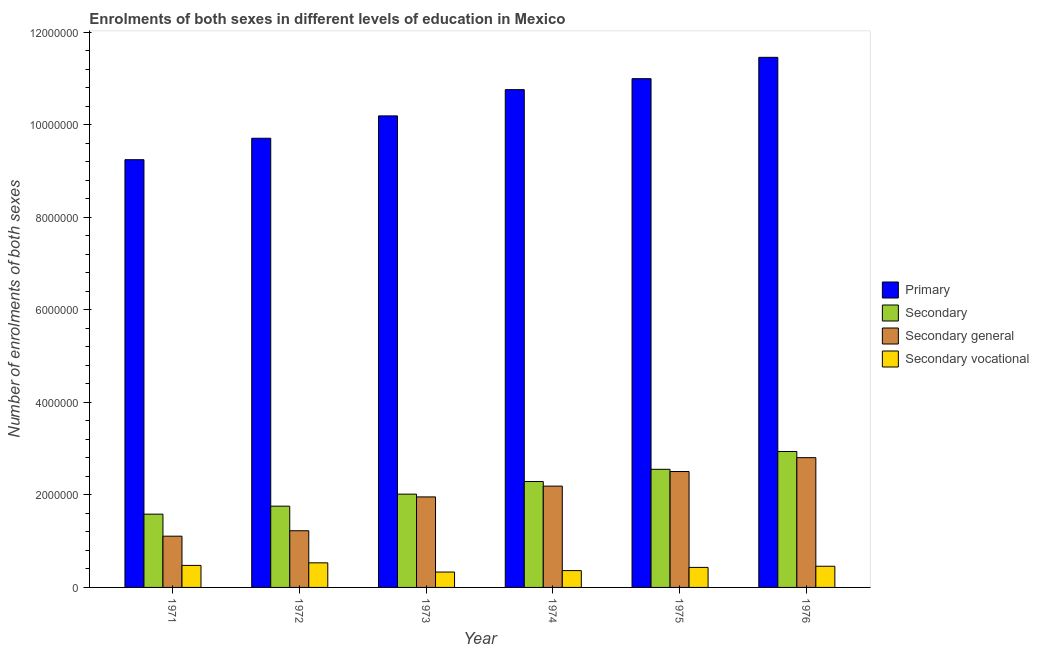How many different coloured bars are there?
Offer a very short reply. 4. Are the number of bars per tick equal to the number of legend labels?
Your answer should be compact. Yes. What is the label of the 4th group of bars from the left?
Your answer should be very brief. 1974. In how many cases, is the number of bars for a given year not equal to the number of legend labels?
Your response must be concise. 0. What is the number of enrolments in secondary education in 1971?
Offer a very short reply. 1.58e+06. Across all years, what is the maximum number of enrolments in secondary general education?
Ensure brevity in your answer.  2.81e+06. Across all years, what is the minimum number of enrolments in secondary education?
Provide a short and direct response. 1.58e+06. In which year was the number of enrolments in secondary general education minimum?
Your response must be concise. 1971. What is the total number of enrolments in secondary general education in the graph?
Give a very brief answer. 1.18e+07. What is the difference between the number of enrolments in secondary vocational education in 1974 and that in 1975?
Give a very brief answer. -6.93e+04. What is the difference between the number of enrolments in secondary general education in 1974 and the number of enrolments in secondary education in 1976?
Provide a short and direct response. -6.15e+05. What is the average number of enrolments in primary education per year?
Make the answer very short. 1.04e+07. In the year 1976, what is the difference between the number of enrolments in primary education and number of enrolments in secondary vocational education?
Provide a succinct answer. 0. In how many years, is the number of enrolments in secondary vocational education greater than 3200000?
Your response must be concise. 0. What is the ratio of the number of enrolments in secondary education in 1974 to that in 1976?
Your response must be concise. 0.78. Is the number of enrolments in secondary general education in 1971 less than that in 1972?
Your answer should be very brief. Yes. What is the difference between the highest and the second highest number of enrolments in secondary vocational education?
Offer a very short reply. 5.51e+04. What is the difference between the highest and the lowest number of enrolments in secondary vocational education?
Offer a very short reply. 1.99e+05. Is the sum of the number of enrolments in primary education in 1972 and 1975 greater than the maximum number of enrolments in secondary education across all years?
Make the answer very short. Yes. Is it the case that in every year, the sum of the number of enrolments in secondary vocational education and number of enrolments in primary education is greater than the sum of number of enrolments in secondary education and number of enrolments in secondary general education?
Keep it short and to the point. No. What does the 4th bar from the left in 1975 represents?
Keep it short and to the point. Secondary vocational. What does the 3rd bar from the right in 1973 represents?
Keep it short and to the point. Secondary. Is it the case that in every year, the sum of the number of enrolments in primary education and number of enrolments in secondary education is greater than the number of enrolments in secondary general education?
Give a very brief answer. Yes. How many bars are there?
Your answer should be very brief. 24. Are all the bars in the graph horizontal?
Ensure brevity in your answer.  No. Does the graph contain any zero values?
Provide a succinct answer. No. Where does the legend appear in the graph?
Give a very brief answer. Center right. How many legend labels are there?
Provide a short and direct response. 4. What is the title of the graph?
Offer a terse response. Enrolments of both sexes in different levels of education in Mexico. What is the label or title of the Y-axis?
Ensure brevity in your answer.  Number of enrolments of both sexes. What is the Number of enrolments of both sexes of Primary in 1971?
Offer a very short reply. 9.25e+06. What is the Number of enrolments of both sexes in Secondary in 1971?
Provide a short and direct response. 1.58e+06. What is the Number of enrolments of both sexes in Secondary general in 1971?
Your response must be concise. 1.11e+06. What is the Number of enrolments of both sexes in Secondary vocational in 1971?
Give a very brief answer. 4.76e+05. What is the Number of enrolments of both sexes of Primary in 1972?
Your response must be concise. 9.71e+06. What is the Number of enrolments of both sexes in Secondary in 1972?
Your answer should be compact. 1.76e+06. What is the Number of enrolments of both sexes of Secondary general in 1972?
Provide a succinct answer. 1.23e+06. What is the Number of enrolments of both sexes in Secondary vocational in 1972?
Your response must be concise. 5.32e+05. What is the Number of enrolments of both sexes of Primary in 1973?
Keep it short and to the point. 1.02e+07. What is the Number of enrolments of both sexes of Secondary in 1973?
Your answer should be very brief. 2.02e+06. What is the Number of enrolments of both sexes of Secondary general in 1973?
Keep it short and to the point. 1.96e+06. What is the Number of enrolments of both sexes of Secondary vocational in 1973?
Your answer should be very brief. 3.33e+05. What is the Number of enrolments of both sexes of Primary in 1974?
Provide a short and direct response. 1.08e+07. What is the Number of enrolments of both sexes of Secondary in 1974?
Offer a very short reply. 2.29e+06. What is the Number of enrolments of both sexes of Secondary general in 1974?
Your answer should be compact. 2.19e+06. What is the Number of enrolments of both sexes of Secondary vocational in 1974?
Offer a very short reply. 3.64e+05. What is the Number of enrolments of both sexes of Primary in 1975?
Offer a terse response. 1.10e+07. What is the Number of enrolments of both sexes in Secondary in 1975?
Offer a very short reply. 2.55e+06. What is the Number of enrolments of both sexes of Secondary general in 1975?
Keep it short and to the point. 2.51e+06. What is the Number of enrolments of both sexes of Secondary vocational in 1975?
Provide a short and direct response. 4.33e+05. What is the Number of enrolments of both sexes of Primary in 1976?
Offer a terse response. 1.15e+07. What is the Number of enrolments of both sexes of Secondary in 1976?
Offer a very short reply. 2.94e+06. What is the Number of enrolments of both sexes of Secondary general in 1976?
Make the answer very short. 2.81e+06. What is the Number of enrolments of both sexes in Secondary vocational in 1976?
Your answer should be very brief. 4.58e+05. Across all years, what is the maximum Number of enrolments of both sexes of Primary?
Give a very brief answer. 1.15e+07. Across all years, what is the maximum Number of enrolments of both sexes of Secondary?
Provide a short and direct response. 2.94e+06. Across all years, what is the maximum Number of enrolments of both sexes in Secondary general?
Offer a terse response. 2.81e+06. Across all years, what is the maximum Number of enrolments of both sexes of Secondary vocational?
Your answer should be very brief. 5.32e+05. Across all years, what is the minimum Number of enrolments of both sexes in Primary?
Your answer should be compact. 9.25e+06. Across all years, what is the minimum Number of enrolments of both sexes of Secondary?
Your answer should be compact. 1.58e+06. Across all years, what is the minimum Number of enrolments of both sexes of Secondary general?
Your answer should be very brief. 1.11e+06. Across all years, what is the minimum Number of enrolments of both sexes in Secondary vocational?
Your response must be concise. 3.33e+05. What is the total Number of enrolments of both sexes of Primary in the graph?
Your answer should be compact. 6.24e+07. What is the total Number of enrolments of both sexes in Secondary in the graph?
Your answer should be compact. 1.31e+07. What is the total Number of enrolments of both sexes of Secondary general in the graph?
Ensure brevity in your answer.  1.18e+07. What is the total Number of enrolments of both sexes in Secondary vocational in the graph?
Provide a short and direct response. 2.60e+06. What is the difference between the Number of enrolments of both sexes in Primary in 1971 and that in 1972?
Offer a very short reply. -4.63e+05. What is the difference between the Number of enrolments of both sexes in Secondary in 1971 and that in 1972?
Your answer should be very brief. -1.73e+05. What is the difference between the Number of enrolments of both sexes of Secondary general in 1971 and that in 1972?
Provide a short and direct response. -1.18e+05. What is the difference between the Number of enrolments of both sexes in Secondary vocational in 1971 and that in 1972?
Your answer should be compact. -5.51e+04. What is the difference between the Number of enrolments of both sexes of Primary in 1971 and that in 1973?
Keep it short and to the point. -9.47e+05. What is the difference between the Number of enrolments of both sexes in Secondary in 1971 and that in 1973?
Give a very brief answer. -4.33e+05. What is the difference between the Number of enrolments of both sexes of Secondary general in 1971 and that in 1973?
Your answer should be very brief. -8.49e+05. What is the difference between the Number of enrolments of both sexes of Secondary vocational in 1971 and that in 1973?
Your response must be concise. 1.44e+05. What is the difference between the Number of enrolments of both sexes of Primary in 1971 and that in 1974?
Your answer should be very brief. -1.51e+06. What is the difference between the Number of enrolments of both sexes of Secondary in 1971 and that in 1974?
Your answer should be compact. -7.06e+05. What is the difference between the Number of enrolments of both sexes in Secondary general in 1971 and that in 1974?
Give a very brief answer. -1.08e+06. What is the difference between the Number of enrolments of both sexes in Secondary vocational in 1971 and that in 1974?
Keep it short and to the point. 1.13e+05. What is the difference between the Number of enrolments of both sexes of Primary in 1971 and that in 1975?
Your answer should be compact. -1.75e+06. What is the difference between the Number of enrolments of both sexes of Secondary in 1971 and that in 1975?
Your answer should be very brief. -9.70e+05. What is the difference between the Number of enrolments of both sexes in Secondary general in 1971 and that in 1975?
Give a very brief answer. -1.40e+06. What is the difference between the Number of enrolments of both sexes in Secondary vocational in 1971 and that in 1975?
Offer a terse response. 4.35e+04. What is the difference between the Number of enrolments of both sexes in Primary in 1971 and that in 1976?
Give a very brief answer. -2.21e+06. What is the difference between the Number of enrolments of both sexes of Secondary in 1971 and that in 1976?
Keep it short and to the point. -1.35e+06. What is the difference between the Number of enrolments of both sexes of Secondary general in 1971 and that in 1976?
Your answer should be very brief. -1.70e+06. What is the difference between the Number of enrolments of both sexes of Secondary vocational in 1971 and that in 1976?
Your answer should be very brief. 1.84e+04. What is the difference between the Number of enrolments of both sexes in Primary in 1972 and that in 1973?
Provide a short and direct response. -4.84e+05. What is the difference between the Number of enrolments of both sexes of Secondary in 1972 and that in 1973?
Make the answer very short. -2.60e+05. What is the difference between the Number of enrolments of both sexes in Secondary general in 1972 and that in 1973?
Provide a succinct answer. -7.32e+05. What is the difference between the Number of enrolments of both sexes of Secondary vocational in 1972 and that in 1973?
Ensure brevity in your answer.  1.99e+05. What is the difference between the Number of enrolments of both sexes of Primary in 1972 and that in 1974?
Offer a very short reply. -1.05e+06. What is the difference between the Number of enrolments of both sexes in Secondary in 1972 and that in 1974?
Make the answer very short. -5.33e+05. What is the difference between the Number of enrolments of both sexes of Secondary general in 1972 and that in 1974?
Make the answer very short. -9.65e+05. What is the difference between the Number of enrolments of both sexes in Secondary vocational in 1972 and that in 1974?
Your answer should be compact. 1.68e+05. What is the difference between the Number of enrolments of both sexes in Primary in 1972 and that in 1975?
Keep it short and to the point. -1.29e+06. What is the difference between the Number of enrolments of both sexes in Secondary in 1972 and that in 1975?
Make the answer very short. -7.97e+05. What is the difference between the Number of enrolments of both sexes of Secondary general in 1972 and that in 1975?
Keep it short and to the point. -1.28e+06. What is the difference between the Number of enrolments of both sexes in Secondary vocational in 1972 and that in 1975?
Offer a terse response. 9.86e+04. What is the difference between the Number of enrolments of both sexes of Primary in 1972 and that in 1976?
Your answer should be very brief. -1.75e+06. What is the difference between the Number of enrolments of both sexes of Secondary in 1972 and that in 1976?
Keep it short and to the point. -1.18e+06. What is the difference between the Number of enrolments of both sexes in Secondary general in 1972 and that in 1976?
Keep it short and to the point. -1.58e+06. What is the difference between the Number of enrolments of both sexes of Secondary vocational in 1972 and that in 1976?
Give a very brief answer. 7.35e+04. What is the difference between the Number of enrolments of both sexes of Primary in 1973 and that in 1974?
Make the answer very short. -5.67e+05. What is the difference between the Number of enrolments of both sexes in Secondary in 1973 and that in 1974?
Ensure brevity in your answer.  -2.73e+05. What is the difference between the Number of enrolments of both sexes of Secondary general in 1973 and that in 1974?
Offer a very short reply. -2.33e+05. What is the difference between the Number of enrolments of both sexes in Secondary vocational in 1973 and that in 1974?
Ensure brevity in your answer.  -3.09e+04. What is the difference between the Number of enrolments of both sexes of Primary in 1973 and that in 1975?
Ensure brevity in your answer.  -8.05e+05. What is the difference between the Number of enrolments of both sexes in Secondary in 1973 and that in 1975?
Provide a succinct answer. -5.37e+05. What is the difference between the Number of enrolments of both sexes of Secondary general in 1973 and that in 1975?
Offer a terse response. -5.49e+05. What is the difference between the Number of enrolments of both sexes in Secondary vocational in 1973 and that in 1975?
Provide a short and direct response. -1.00e+05. What is the difference between the Number of enrolments of both sexes in Primary in 1973 and that in 1976?
Offer a very short reply. -1.27e+06. What is the difference between the Number of enrolments of both sexes of Secondary in 1973 and that in 1976?
Offer a terse response. -9.22e+05. What is the difference between the Number of enrolments of both sexes of Secondary general in 1973 and that in 1976?
Make the answer very short. -8.48e+05. What is the difference between the Number of enrolments of both sexes of Secondary vocational in 1973 and that in 1976?
Your response must be concise. -1.25e+05. What is the difference between the Number of enrolments of both sexes of Primary in 1974 and that in 1975?
Provide a short and direct response. -2.37e+05. What is the difference between the Number of enrolments of both sexes in Secondary in 1974 and that in 1975?
Offer a terse response. -2.64e+05. What is the difference between the Number of enrolments of both sexes of Secondary general in 1974 and that in 1975?
Give a very brief answer. -3.16e+05. What is the difference between the Number of enrolments of both sexes in Secondary vocational in 1974 and that in 1975?
Give a very brief answer. -6.93e+04. What is the difference between the Number of enrolments of both sexes of Primary in 1974 and that in 1976?
Your answer should be compact. -6.99e+05. What is the difference between the Number of enrolments of both sexes of Secondary in 1974 and that in 1976?
Your response must be concise. -6.49e+05. What is the difference between the Number of enrolments of both sexes in Secondary general in 1974 and that in 1976?
Offer a terse response. -6.15e+05. What is the difference between the Number of enrolments of both sexes of Secondary vocational in 1974 and that in 1976?
Offer a very short reply. -9.44e+04. What is the difference between the Number of enrolments of both sexes in Primary in 1975 and that in 1976?
Provide a short and direct response. -4.62e+05. What is the difference between the Number of enrolments of both sexes of Secondary in 1975 and that in 1976?
Your response must be concise. -3.85e+05. What is the difference between the Number of enrolments of both sexes of Secondary general in 1975 and that in 1976?
Offer a very short reply. -2.99e+05. What is the difference between the Number of enrolments of both sexes in Secondary vocational in 1975 and that in 1976?
Ensure brevity in your answer.  -2.51e+04. What is the difference between the Number of enrolments of both sexes in Primary in 1971 and the Number of enrolments of both sexes in Secondary in 1972?
Your answer should be very brief. 7.49e+06. What is the difference between the Number of enrolments of both sexes of Primary in 1971 and the Number of enrolments of both sexes of Secondary general in 1972?
Your answer should be compact. 8.02e+06. What is the difference between the Number of enrolments of both sexes of Primary in 1971 and the Number of enrolments of both sexes of Secondary vocational in 1972?
Your response must be concise. 8.72e+06. What is the difference between the Number of enrolments of both sexes in Secondary in 1971 and the Number of enrolments of both sexes in Secondary general in 1972?
Provide a short and direct response. 3.59e+05. What is the difference between the Number of enrolments of both sexes in Secondary in 1971 and the Number of enrolments of both sexes in Secondary vocational in 1972?
Offer a very short reply. 1.05e+06. What is the difference between the Number of enrolments of both sexes in Secondary general in 1971 and the Number of enrolments of both sexes in Secondary vocational in 1972?
Offer a very short reply. 5.76e+05. What is the difference between the Number of enrolments of both sexes in Primary in 1971 and the Number of enrolments of both sexes in Secondary in 1973?
Make the answer very short. 7.23e+06. What is the difference between the Number of enrolments of both sexes in Primary in 1971 and the Number of enrolments of both sexes in Secondary general in 1973?
Offer a very short reply. 7.29e+06. What is the difference between the Number of enrolments of both sexes in Primary in 1971 and the Number of enrolments of both sexes in Secondary vocational in 1973?
Offer a very short reply. 8.92e+06. What is the difference between the Number of enrolments of both sexes in Secondary in 1971 and the Number of enrolments of both sexes in Secondary general in 1973?
Offer a very short reply. -3.73e+05. What is the difference between the Number of enrolments of both sexes in Secondary in 1971 and the Number of enrolments of both sexes in Secondary vocational in 1973?
Give a very brief answer. 1.25e+06. What is the difference between the Number of enrolments of both sexes in Secondary general in 1971 and the Number of enrolments of both sexes in Secondary vocational in 1973?
Keep it short and to the point. 7.75e+05. What is the difference between the Number of enrolments of both sexes in Primary in 1971 and the Number of enrolments of both sexes in Secondary in 1974?
Provide a succinct answer. 6.96e+06. What is the difference between the Number of enrolments of both sexes of Primary in 1971 and the Number of enrolments of both sexes of Secondary general in 1974?
Your answer should be compact. 7.06e+06. What is the difference between the Number of enrolments of both sexes in Primary in 1971 and the Number of enrolments of both sexes in Secondary vocational in 1974?
Ensure brevity in your answer.  8.88e+06. What is the difference between the Number of enrolments of both sexes of Secondary in 1971 and the Number of enrolments of both sexes of Secondary general in 1974?
Ensure brevity in your answer.  -6.06e+05. What is the difference between the Number of enrolments of both sexes in Secondary in 1971 and the Number of enrolments of both sexes in Secondary vocational in 1974?
Offer a terse response. 1.22e+06. What is the difference between the Number of enrolments of both sexes of Secondary general in 1971 and the Number of enrolments of both sexes of Secondary vocational in 1974?
Your answer should be very brief. 7.44e+05. What is the difference between the Number of enrolments of both sexes in Primary in 1971 and the Number of enrolments of both sexes in Secondary in 1975?
Your answer should be very brief. 6.69e+06. What is the difference between the Number of enrolments of both sexes of Primary in 1971 and the Number of enrolments of both sexes of Secondary general in 1975?
Keep it short and to the point. 6.74e+06. What is the difference between the Number of enrolments of both sexes of Primary in 1971 and the Number of enrolments of both sexes of Secondary vocational in 1975?
Ensure brevity in your answer.  8.82e+06. What is the difference between the Number of enrolments of both sexes of Secondary in 1971 and the Number of enrolments of both sexes of Secondary general in 1975?
Your answer should be very brief. -9.22e+05. What is the difference between the Number of enrolments of both sexes in Secondary in 1971 and the Number of enrolments of both sexes in Secondary vocational in 1975?
Provide a succinct answer. 1.15e+06. What is the difference between the Number of enrolments of both sexes in Secondary general in 1971 and the Number of enrolments of both sexes in Secondary vocational in 1975?
Give a very brief answer. 6.75e+05. What is the difference between the Number of enrolments of both sexes in Primary in 1971 and the Number of enrolments of both sexes in Secondary in 1976?
Offer a terse response. 6.31e+06. What is the difference between the Number of enrolments of both sexes of Primary in 1971 and the Number of enrolments of both sexes of Secondary general in 1976?
Your answer should be very brief. 6.44e+06. What is the difference between the Number of enrolments of both sexes in Primary in 1971 and the Number of enrolments of both sexes in Secondary vocational in 1976?
Keep it short and to the point. 8.79e+06. What is the difference between the Number of enrolments of both sexes in Secondary in 1971 and the Number of enrolments of both sexes in Secondary general in 1976?
Offer a terse response. -1.22e+06. What is the difference between the Number of enrolments of both sexes of Secondary in 1971 and the Number of enrolments of both sexes of Secondary vocational in 1976?
Provide a succinct answer. 1.13e+06. What is the difference between the Number of enrolments of both sexes of Secondary general in 1971 and the Number of enrolments of both sexes of Secondary vocational in 1976?
Give a very brief answer. 6.50e+05. What is the difference between the Number of enrolments of both sexes of Primary in 1972 and the Number of enrolments of both sexes of Secondary in 1973?
Keep it short and to the point. 7.69e+06. What is the difference between the Number of enrolments of both sexes of Primary in 1972 and the Number of enrolments of both sexes of Secondary general in 1973?
Your response must be concise. 7.75e+06. What is the difference between the Number of enrolments of both sexes of Primary in 1972 and the Number of enrolments of both sexes of Secondary vocational in 1973?
Keep it short and to the point. 9.38e+06. What is the difference between the Number of enrolments of both sexes in Secondary in 1972 and the Number of enrolments of both sexes in Secondary general in 1973?
Provide a short and direct response. -2.00e+05. What is the difference between the Number of enrolments of both sexes of Secondary in 1972 and the Number of enrolments of both sexes of Secondary vocational in 1973?
Your answer should be compact. 1.42e+06. What is the difference between the Number of enrolments of both sexes in Secondary general in 1972 and the Number of enrolments of both sexes in Secondary vocational in 1973?
Offer a terse response. 8.93e+05. What is the difference between the Number of enrolments of both sexes in Primary in 1972 and the Number of enrolments of both sexes in Secondary in 1974?
Give a very brief answer. 7.42e+06. What is the difference between the Number of enrolments of both sexes of Primary in 1972 and the Number of enrolments of both sexes of Secondary general in 1974?
Make the answer very short. 7.52e+06. What is the difference between the Number of enrolments of both sexes in Primary in 1972 and the Number of enrolments of both sexes in Secondary vocational in 1974?
Provide a succinct answer. 9.35e+06. What is the difference between the Number of enrolments of both sexes of Secondary in 1972 and the Number of enrolments of both sexes of Secondary general in 1974?
Keep it short and to the point. -4.33e+05. What is the difference between the Number of enrolments of both sexes in Secondary in 1972 and the Number of enrolments of both sexes in Secondary vocational in 1974?
Make the answer very short. 1.39e+06. What is the difference between the Number of enrolments of both sexes of Secondary general in 1972 and the Number of enrolments of both sexes of Secondary vocational in 1974?
Offer a terse response. 8.62e+05. What is the difference between the Number of enrolments of both sexes of Primary in 1972 and the Number of enrolments of both sexes of Secondary in 1975?
Provide a succinct answer. 7.16e+06. What is the difference between the Number of enrolments of both sexes of Primary in 1972 and the Number of enrolments of both sexes of Secondary general in 1975?
Offer a terse response. 7.21e+06. What is the difference between the Number of enrolments of both sexes in Primary in 1972 and the Number of enrolments of both sexes in Secondary vocational in 1975?
Keep it short and to the point. 9.28e+06. What is the difference between the Number of enrolments of both sexes in Secondary in 1972 and the Number of enrolments of both sexes in Secondary general in 1975?
Your answer should be compact. -7.49e+05. What is the difference between the Number of enrolments of both sexes of Secondary in 1972 and the Number of enrolments of both sexes of Secondary vocational in 1975?
Give a very brief answer. 1.32e+06. What is the difference between the Number of enrolments of both sexes of Secondary general in 1972 and the Number of enrolments of both sexes of Secondary vocational in 1975?
Ensure brevity in your answer.  7.93e+05. What is the difference between the Number of enrolments of both sexes of Primary in 1972 and the Number of enrolments of both sexes of Secondary in 1976?
Ensure brevity in your answer.  6.77e+06. What is the difference between the Number of enrolments of both sexes of Primary in 1972 and the Number of enrolments of both sexes of Secondary general in 1976?
Keep it short and to the point. 6.91e+06. What is the difference between the Number of enrolments of both sexes in Primary in 1972 and the Number of enrolments of both sexes in Secondary vocational in 1976?
Ensure brevity in your answer.  9.25e+06. What is the difference between the Number of enrolments of both sexes in Secondary in 1972 and the Number of enrolments of both sexes in Secondary general in 1976?
Offer a terse response. -1.05e+06. What is the difference between the Number of enrolments of both sexes of Secondary in 1972 and the Number of enrolments of both sexes of Secondary vocational in 1976?
Provide a short and direct response. 1.30e+06. What is the difference between the Number of enrolments of both sexes of Secondary general in 1972 and the Number of enrolments of both sexes of Secondary vocational in 1976?
Offer a very short reply. 7.67e+05. What is the difference between the Number of enrolments of both sexes of Primary in 1973 and the Number of enrolments of both sexes of Secondary in 1974?
Your answer should be compact. 7.91e+06. What is the difference between the Number of enrolments of both sexes of Primary in 1973 and the Number of enrolments of both sexes of Secondary general in 1974?
Make the answer very short. 8.00e+06. What is the difference between the Number of enrolments of both sexes in Primary in 1973 and the Number of enrolments of both sexes in Secondary vocational in 1974?
Ensure brevity in your answer.  9.83e+06. What is the difference between the Number of enrolments of both sexes of Secondary in 1973 and the Number of enrolments of both sexes of Secondary general in 1974?
Provide a short and direct response. -1.73e+05. What is the difference between the Number of enrolments of both sexes of Secondary in 1973 and the Number of enrolments of both sexes of Secondary vocational in 1974?
Your answer should be compact. 1.65e+06. What is the difference between the Number of enrolments of both sexes in Secondary general in 1973 and the Number of enrolments of both sexes in Secondary vocational in 1974?
Your answer should be very brief. 1.59e+06. What is the difference between the Number of enrolments of both sexes in Primary in 1973 and the Number of enrolments of both sexes in Secondary in 1975?
Offer a very short reply. 7.64e+06. What is the difference between the Number of enrolments of both sexes of Primary in 1973 and the Number of enrolments of both sexes of Secondary general in 1975?
Provide a succinct answer. 7.69e+06. What is the difference between the Number of enrolments of both sexes of Primary in 1973 and the Number of enrolments of both sexes of Secondary vocational in 1975?
Ensure brevity in your answer.  9.76e+06. What is the difference between the Number of enrolments of both sexes in Secondary in 1973 and the Number of enrolments of both sexes in Secondary general in 1975?
Give a very brief answer. -4.89e+05. What is the difference between the Number of enrolments of both sexes in Secondary in 1973 and the Number of enrolments of both sexes in Secondary vocational in 1975?
Ensure brevity in your answer.  1.58e+06. What is the difference between the Number of enrolments of both sexes of Secondary general in 1973 and the Number of enrolments of both sexes of Secondary vocational in 1975?
Your answer should be very brief. 1.52e+06. What is the difference between the Number of enrolments of both sexes of Primary in 1973 and the Number of enrolments of both sexes of Secondary in 1976?
Provide a short and direct response. 7.26e+06. What is the difference between the Number of enrolments of both sexes in Primary in 1973 and the Number of enrolments of both sexes in Secondary general in 1976?
Provide a succinct answer. 7.39e+06. What is the difference between the Number of enrolments of both sexes of Primary in 1973 and the Number of enrolments of both sexes of Secondary vocational in 1976?
Make the answer very short. 9.74e+06. What is the difference between the Number of enrolments of both sexes of Secondary in 1973 and the Number of enrolments of both sexes of Secondary general in 1976?
Ensure brevity in your answer.  -7.88e+05. What is the difference between the Number of enrolments of both sexes in Secondary in 1973 and the Number of enrolments of both sexes in Secondary vocational in 1976?
Make the answer very short. 1.56e+06. What is the difference between the Number of enrolments of both sexes of Secondary general in 1973 and the Number of enrolments of both sexes of Secondary vocational in 1976?
Provide a succinct answer. 1.50e+06. What is the difference between the Number of enrolments of both sexes in Primary in 1974 and the Number of enrolments of both sexes in Secondary in 1975?
Give a very brief answer. 8.21e+06. What is the difference between the Number of enrolments of both sexes of Primary in 1974 and the Number of enrolments of both sexes of Secondary general in 1975?
Your answer should be very brief. 8.26e+06. What is the difference between the Number of enrolments of both sexes in Primary in 1974 and the Number of enrolments of both sexes in Secondary vocational in 1975?
Make the answer very short. 1.03e+07. What is the difference between the Number of enrolments of both sexes of Secondary in 1974 and the Number of enrolments of both sexes of Secondary general in 1975?
Keep it short and to the point. -2.16e+05. What is the difference between the Number of enrolments of both sexes in Secondary in 1974 and the Number of enrolments of both sexes in Secondary vocational in 1975?
Offer a very short reply. 1.86e+06. What is the difference between the Number of enrolments of both sexes of Secondary general in 1974 and the Number of enrolments of both sexes of Secondary vocational in 1975?
Give a very brief answer. 1.76e+06. What is the difference between the Number of enrolments of both sexes in Primary in 1974 and the Number of enrolments of both sexes in Secondary in 1976?
Provide a short and direct response. 7.82e+06. What is the difference between the Number of enrolments of both sexes of Primary in 1974 and the Number of enrolments of both sexes of Secondary general in 1976?
Make the answer very short. 7.96e+06. What is the difference between the Number of enrolments of both sexes of Primary in 1974 and the Number of enrolments of both sexes of Secondary vocational in 1976?
Your answer should be very brief. 1.03e+07. What is the difference between the Number of enrolments of both sexes of Secondary in 1974 and the Number of enrolments of both sexes of Secondary general in 1976?
Give a very brief answer. -5.16e+05. What is the difference between the Number of enrolments of both sexes in Secondary in 1974 and the Number of enrolments of both sexes in Secondary vocational in 1976?
Your answer should be very brief. 1.83e+06. What is the difference between the Number of enrolments of both sexes in Secondary general in 1974 and the Number of enrolments of both sexes in Secondary vocational in 1976?
Your answer should be compact. 1.73e+06. What is the difference between the Number of enrolments of both sexes of Primary in 1975 and the Number of enrolments of both sexes of Secondary in 1976?
Ensure brevity in your answer.  8.06e+06. What is the difference between the Number of enrolments of both sexes of Primary in 1975 and the Number of enrolments of both sexes of Secondary general in 1976?
Offer a terse response. 8.19e+06. What is the difference between the Number of enrolments of both sexes in Primary in 1975 and the Number of enrolments of both sexes in Secondary vocational in 1976?
Provide a succinct answer. 1.05e+07. What is the difference between the Number of enrolments of both sexes of Secondary in 1975 and the Number of enrolments of both sexes of Secondary general in 1976?
Ensure brevity in your answer.  -2.51e+05. What is the difference between the Number of enrolments of both sexes of Secondary in 1975 and the Number of enrolments of both sexes of Secondary vocational in 1976?
Make the answer very short. 2.10e+06. What is the difference between the Number of enrolments of both sexes of Secondary general in 1975 and the Number of enrolments of both sexes of Secondary vocational in 1976?
Your answer should be compact. 2.05e+06. What is the average Number of enrolments of both sexes of Primary per year?
Offer a terse response. 1.04e+07. What is the average Number of enrolments of both sexes in Secondary per year?
Provide a succinct answer. 2.19e+06. What is the average Number of enrolments of both sexes of Secondary general per year?
Offer a very short reply. 1.97e+06. What is the average Number of enrolments of both sexes in Secondary vocational per year?
Your answer should be very brief. 4.33e+05. In the year 1971, what is the difference between the Number of enrolments of both sexes in Primary and Number of enrolments of both sexes in Secondary?
Offer a terse response. 7.66e+06. In the year 1971, what is the difference between the Number of enrolments of both sexes in Primary and Number of enrolments of both sexes in Secondary general?
Keep it short and to the point. 8.14e+06. In the year 1971, what is the difference between the Number of enrolments of both sexes in Primary and Number of enrolments of both sexes in Secondary vocational?
Offer a very short reply. 8.77e+06. In the year 1971, what is the difference between the Number of enrolments of both sexes of Secondary and Number of enrolments of both sexes of Secondary general?
Give a very brief answer. 4.76e+05. In the year 1971, what is the difference between the Number of enrolments of both sexes of Secondary and Number of enrolments of both sexes of Secondary vocational?
Your answer should be very brief. 1.11e+06. In the year 1971, what is the difference between the Number of enrolments of both sexes in Secondary general and Number of enrolments of both sexes in Secondary vocational?
Provide a short and direct response. 6.31e+05. In the year 1972, what is the difference between the Number of enrolments of both sexes in Primary and Number of enrolments of both sexes in Secondary?
Give a very brief answer. 7.95e+06. In the year 1972, what is the difference between the Number of enrolments of both sexes in Primary and Number of enrolments of both sexes in Secondary general?
Your answer should be very brief. 8.49e+06. In the year 1972, what is the difference between the Number of enrolments of both sexes of Primary and Number of enrolments of both sexes of Secondary vocational?
Offer a terse response. 9.18e+06. In the year 1972, what is the difference between the Number of enrolments of both sexes in Secondary and Number of enrolments of both sexes in Secondary general?
Your response must be concise. 5.32e+05. In the year 1972, what is the difference between the Number of enrolments of both sexes in Secondary and Number of enrolments of both sexes in Secondary vocational?
Your response must be concise. 1.23e+06. In the year 1972, what is the difference between the Number of enrolments of both sexes in Secondary general and Number of enrolments of both sexes in Secondary vocational?
Ensure brevity in your answer.  6.94e+05. In the year 1973, what is the difference between the Number of enrolments of both sexes in Primary and Number of enrolments of both sexes in Secondary?
Provide a succinct answer. 8.18e+06. In the year 1973, what is the difference between the Number of enrolments of both sexes of Primary and Number of enrolments of both sexes of Secondary general?
Give a very brief answer. 8.24e+06. In the year 1973, what is the difference between the Number of enrolments of both sexes of Primary and Number of enrolments of both sexes of Secondary vocational?
Offer a terse response. 9.86e+06. In the year 1973, what is the difference between the Number of enrolments of both sexes in Secondary and Number of enrolments of both sexes in Secondary general?
Your answer should be compact. 6.00e+04. In the year 1973, what is the difference between the Number of enrolments of both sexes of Secondary and Number of enrolments of both sexes of Secondary vocational?
Give a very brief answer. 1.68e+06. In the year 1973, what is the difference between the Number of enrolments of both sexes of Secondary general and Number of enrolments of both sexes of Secondary vocational?
Ensure brevity in your answer.  1.62e+06. In the year 1974, what is the difference between the Number of enrolments of both sexes of Primary and Number of enrolments of both sexes of Secondary?
Ensure brevity in your answer.  8.47e+06. In the year 1974, what is the difference between the Number of enrolments of both sexes in Primary and Number of enrolments of both sexes in Secondary general?
Give a very brief answer. 8.57e+06. In the year 1974, what is the difference between the Number of enrolments of both sexes in Primary and Number of enrolments of both sexes in Secondary vocational?
Keep it short and to the point. 1.04e+07. In the year 1974, what is the difference between the Number of enrolments of both sexes of Secondary and Number of enrolments of both sexes of Secondary general?
Offer a terse response. 9.94e+04. In the year 1974, what is the difference between the Number of enrolments of both sexes of Secondary and Number of enrolments of both sexes of Secondary vocational?
Offer a terse response. 1.93e+06. In the year 1974, what is the difference between the Number of enrolments of both sexes of Secondary general and Number of enrolments of both sexes of Secondary vocational?
Offer a terse response. 1.83e+06. In the year 1975, what is the difference between the Number of enrolments of both sexes of Primary and Number of enrolments of both sexes of Secondary?
Provide a succinct answer. 8.45e+06. In the year 1975, what is the difference between the Number of enrolments of both sexes in Primary and Number of enrolments of both sexes in Secondary general?
Your answer should be compact. 8.49e+06. In the year 1975, what is the difference between the Number of enrolments of both sexes in Primary and Number of enrolments of both sexes in Secondary vocational?
Offer a very short reply. 1.06e+07. In the year 1975, what is the difference between the Number of enrolments of both sexes in Secondary and Number of enrolments of both sexes in Secondary general?
Offer a very short reply. 4.80e+04. In the year 1975, what is the difference between the Number of enrolments of both sexes of Secondary and Number of enrolments of both sexes of Secondary vocational?
Offer a very short reply. 2.12e+06. In the year 1975, what is the difference between the Number of enrolments of both sexes of Secondary general and Number of enrolments of both sexes of Secondary vocational?
Offer a terse response. 2.07e+06. In the year 1976, what is the difference between the Number of enrolments of both sexes of Primary and Number of enrolments of both sexes of Secondary?
Ensure brevity in your answer.  8.52e+06. In the year 1976, what is the difference between the Number of enrolments of both sexes of Primary and Number of enrolments of both sexes of Secondary general?
Your response must be concise. 8.66e+06. In the year 1976, what is the difference between the Number of enrolments of both sexes in Primary and Number of enrolments of both sexes in Secondary vocational?
Ensure brevity in your answer.  1.10e+07. In the year 1976, what is the difference between the Number of enrolments of both sexes of Secondary and Number of enrolments of both sexes of Secondary general?
Ensure brevity in your answer.  1.33e+05. In the year 1976, what is the difference between the Number of enrolments of both sexes of Secondary and Number of enrolments of both sexes of Secondary vocational?
Make the answer very short. 2.48e+06. In the year 1976, what is the difference between the Number of enrolments of both sexes of Secondary general and Number of enrolments of both sexes of Secondary vocational?
Your answer should be compact. 2.35e+06. What is the ratio of the Number of enrolments of both sexes in Primary in 1971 to that in 1972?
Offer a terse response. 0.95. What is the ratio of the Number of enrolments of both sexes in Secondary in 1971 to that in 1972?
Provide a succinct answer. 0.9. What is the ratio of the Number of enrolments of both sexes of Secondary general in 1971 to that in 1972?
Ensure brevity in your answer.  0.9. What is the ratio of the Number of enrolments of both sexes in Secondary vocational in 1971 to that in 1972?
Make the answer very short. 0.9. What is the ratio of the Number of enrolments of both sexes in Primary in 1971 to that in 1973?
Offer a terse response. 0.91. What is the ratio of the Number of enrolments of both sexes of Secondary in 1971 to that in 1973?
Ensure brevity in your answer.  0.79. What is the ratio of the Number of enrolments of both sexes of Secondary general in 1971 to that in 1973?
Offer a terse response. 0.57. What is the ratio of the Number of enrolments of both sexes in Secondary vocational in 1971 to that in 1973?
Your response must be concise. 1.43. What is the ratio of the Number of enrolments of both sexes of Primary in 1971 to that in 1974?
Your answer should be very brief. 0.86. What is the ratio of the Number of enrolments of both sexes of Secondary in 1971 to that in 1974?
Provide a succinct answer. 0.69. What is the ratio of the Number of enrolments of both sexes in Secondary general in 1971 to that in 1974?
Provide a short and direct response. 0.51. What is the ratio of the Number of enrolments of both sexes in Secondary vocational in 1971 to that in 1974?
Provide a short and direct response. 1.31. What is the ratio of the Number of enrolments of both sexes in Primary in 1971 to that in 1975?
Provide a short and direct response. 0.84. What is the ratio of the Number of enrolments of both sexes of Secondary in 1971 to that in 1975?
Give a very brief answer. 0.62. What is the ratio of the Number of enrolments of both sexes in Secondary general in 1971 to that in 1975?
Your answer should be compact. 0.44. What is the ratio of the Number of enrolments of both sexes in Secondary vocational in 1971 to that in 1975?
Provide a short and direct response. 1.1. What is the ratio of the Number of enrolments of both sexes in Primary in 1971 to that in 1976?
Offer a terse response. 0.81. What is the ratio of the Number of enrolments of both sexes in Secondary in 1971 to that in 1976?
Ensure brevity in your answer.  0.54. What is the ratio of the Number of enrolments of both sexes in Secondary general in 1971 to that in 1976?
Provide a short and direct response. 0.39. What is the ratio of the Number of enrolments of both sexes in Secondary vocational in 1971 to that in 1976?
Offer a terse response. 1.04. What is the ratio of the Number of enrolments of both sexes in Primary in 1972 to that in 1973?
Make the answer very short. 0.95. What is the ratio of the Number of enrolments of both sexes of Secondary in 1972 to that in 1973?
Offer a very short reply. 0.87. What is the ratio of the Number of enrolments of both sexes in Secondary general in 1972 to that in 1973?
Make the answer very short. 0.63. What is the ratio of the Number of enrolments of both sexes in Secondary vocational in 1972 to that in 1973?
Give a very brief answer. 1.6. What is the ratio of the Number of enrolments of both sexes in Primary in 1972 to that in 1974?
Your answer should be compact. 0.9. What is the ratio of the Number of enrolments of both sexes in Secondary in 1972 to that in 1974?
Offer a terse response. 0.77. What is the ratio of the Number of enrolments of both sexes in Secondary general in 1972 to that in 1974?
Give a very brief answer. 0.56. What is the ratio of the Number of enrolments of both sexes of Secondary vocational in 1972 to that in 1974?
Give a very brief answer. 1.46. What is the ratio of the Number of enrolments of both sexes in Primary in 1972 to that in 1975?
Make the answer very short. 0.88. What is the ratio of the Number of enrolments of both sexes of Secondary in 1972 to that in 1975?
Your answer should be compact. 0.69. What is the ratio of the Number of enrolments of both sexes in Secondary general in 1972 to that in 1975?
Keep it short and to the point. 0.49. What is the ratio of the Number of enrolments of both sexes in Secondary vocational in 1972 to that in 1975?
Your response must be concise. 1.23. What is the ratio of the Number of enrolments of both sexes of Primary in 1972 to that in 1976?
Your response must be concise. 0.85. What is the ratio of the Number of enrolments of both sexes in Secondary in 1972 to that in 1976?
Provide a succinct answer. 0.6. What is the ratio of the Number of enrolments of both sexes of Secondary general in 1972 to that in 1976?
Your answer should be compact. 0.44. What is the ratio of the Number of enrolments of both sexes of Secondary vocational in 1972 to that in 1976?
Provide a short and direct response. 1.16. What is the ratio of the Number of enrolments of both sexes of Primary in 1973 to that in 1974?
Provide a short and direct response. 0.95. What is the ratio of the Number of enrolments of both sexes in Secondary in 1973 to that in 1974?
Give a very brief answer. 0.88. What is the ratio of the Number of enrolments of both sexes of Secondary general in 1973 to that in 1974?
Provide a succinct answer. 0.89. What is the ratio of the Number of enrolments of both sexes in Secondary vocational in 1973 to that in 1974?
Your answer should be very brief. 0.92. What is the ratio of the Number of enrolments of both sexes in Primary in 1973 to that in 1975?
Offer a terse response. 0.93. What is the ratio of the Number of enrolments of both sexes of Secondary in 1973 to that in 1975?
Your answer should be very brief. 0.79. What is the ratio of the Number of enrolments of both sexes of Secondary general in 1973 to that in 1975?
Provide a short and direct response. 0.78. What is the ratio of the Number of enrolments of both sexes in Secondary vocational in 1973 to that in 1975?
Your answer should be very brief. 0.77. What is the ratio of the Number of enrolments of both sexes in Primary in 1973 to that in 1976?
Your answer should be compact. 0.89. What is the ratio of the Number of enrolments of both sexes in Secondary in 1973 to that in 1976?
Make the answer very short. 0.69. What is the ratio of the Number of enrolments of both sexes in Secondary general in 1973 to that in 1976?
Keep it short and to the point. 0.7. What is the ratio of the Number of enrolments of both sexes of Secondary vocational in 1973 to that in 1976?
Your answer should be very brief. 0.73. What is the ratio of the Number of enrolments of both sexes of Primary in 1974 to that in 1975?
Your answer should be very brief. 0.98. What is the ratio of the Number of enrolments of both sexes of Secondary in 1974 to that in 1975?
Offer a very short reply. 0.9. What is the ratio of the Number of enrolments of both sexes of Secondary general in 1974 to that in 1975?
Provide a succinct answer. 0.87. What is the ratio of the Number of enrolments of both sexes of Secondary vocational in 1974 to that in 1975?
Your response must be concise. 0.84. What is the ratio of the Number of enrolments of both sexes in Primary in 1974 to that in 1976?
Provide a short and direct response. 0.94. What is the ratio of the Number of enrolments of both sexes of Secondary in 1974 to that in 1976?
Ensure brevity in your answer.  0.78. What is the ratio of the Number of enrolments of both sexes in Secondary general in 1974 to that in 1976?
Offer a very short reply. 0.78. What is the ratio of the Number of enrolments of both sexes of Secondary vocational in 1974 to that in 1976?
Offer a terse response. 0.79. What is the ratio of the Number of enrolments of both sexes in Primary in 1975 to that in 1976?
Provide a short and direct response. 0.96. What is the ratio of the Number of enrolments of both sexes of Secondary in 1975 to that in 1976?
Keep it short and to the point. 0.87. What is the ratio of the Number of enrolments of both sexes in Secondary general in 1975 to that in 1976?
Your answer should be compact. 0.89. What is the ratio of the Number of enrolments of both sexes of Secondary vocational in 1975 to that in 1976?
Your response must be concise. 0.95. What is the difference between the highest and the second highest Number of enrolments of both sexes in Primary?
Provide a short and direct response. 4.62e+05. What is the difference between the highest and the second highest Number of enrolments of both sexes in Secondary?
Make the answer very short. 3.85e+05. What is the difference between the highest and the second highest Number of enrolments of both sexes in Secondary general?
Give a very brief answer. 2.99e+05. What is the difference between the highest and the second highest Number of enrolments of both sexes of Secondary vocational?
Offer a terse response. 5.51e+04. What is the difference between the highest and the lowest Number of enrolments of both sexes of Primary?
Provide a short and direct response. 2.21e+06. What is the difference between the highest and the lowest Number of enrolments of both sexes in Secondary?
Provide a short and direct response. 1.35e+06. What is the difference between the highest and the lowest Number of enrolments of both sexes of Secondary general?
Provide a short and direct response. 1.70e+06. What is the difference between the highest and the lowest Number of enrolments of both sexes in Secondary vocational?
Keep it short and to the point. 1.99e+05. 